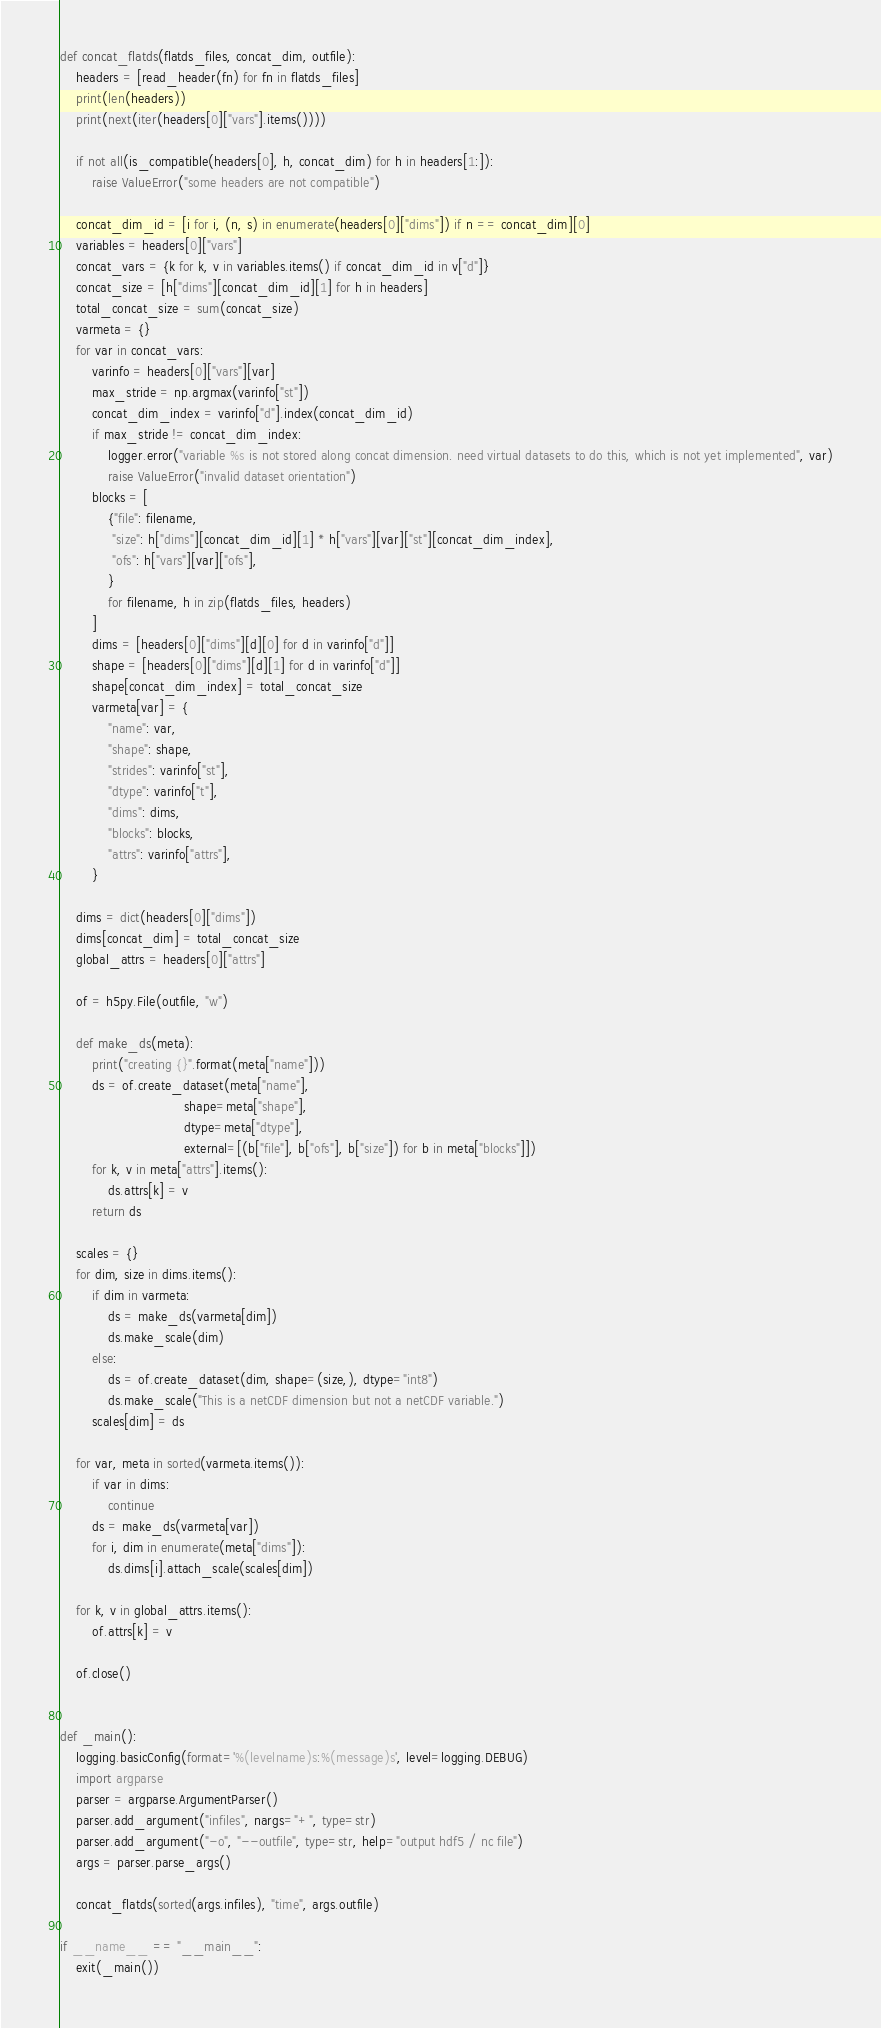<code> <loc_0><loc_0><loc_500><loc_500><_Python_>def concat_flatds(flatds_files, concat_dim, outfile):
    headers = [read_header(fn) for fn in flatds_files]
    print(len(headers))
    print(next(iter(headers[0]["vars"].items())))

    if not all(is_compatible(headers[0], h, concat_dim) for h in headers[1:]):
        raise ValueError("some headers are not compatible")

    concat_dim_id = [i for i, (n, s) in enumerate(headers[0]["dims"]) if n == concat_dim][0]
    variables = headers[0]["vars"]
    concat_vars = {k for k, v in variables.items() if concat_dim_id in v["d"]}
    concat_size = [h["dims"][concat_dim_id][1] for h in headers]
    total_concat_size = sum(concat_size)
    varmeta = {}
    for var in concat_vars:
        varinfo = headers[0]["vars"][var]
        max_stride = np.argmax(varinfo["st"])
        concat_dim_index = varinfo["d"].index(concat_dim_id)
        if max_stride != concat_dim_index:
            logger.error("variable %s is not stored along concat dimension. need virtual datasets to do this, which is not yet implemented", var)
            raise ValueError("invalid dataset orientation")
        blocks = [
            {"file": filename,
             "size": h["dims"][concat_dim_id][1] * h["vars"][var]["st"][concat_dim_index],
             "ofs": h["vars"][var]["ofs"],
            }
            for filename, h in zip(flatds_files, headers)
        ]
        dims = [headers[0]["dims"][d][0] for d in varinfo["d"]]
        shape = [headers[0]["dims"][d][1] for d in varinfo["d"]]
        shape[concat_dim_index] = total_concat_size
        varmeta[var] = {
            "name": var,
            "shape": shape,
            "strides": varinfo["st"],
            "dtype": varinfo["t"],
            "dims": dims,
            "blocks": blocks,
            "attrs": varinfo["attrs"],
        }

    dims = dict(headers[0]["dims"])
    dims[concat_dim] = total_concat_size
    global_attrs = headers[0]["attrs"]

    of = h5py.File(outfile, "w")

    def make_ds(meta):
        print("creating {}".format(meta["name"]))
        ds = of.create_dataset(meta["name"],
                               shape=meta["shape"],
                               dtype=meta["dtype"],
                               external=[(b["file"], b["ofs"], b["size"]) for b in meta["blocks"]])
        for k, v in meta["attrs"].items():
            ds.attrs[k] = v
        return ds

    scales = {}
    for dim, size in dims.items():
        if dim in varmeta:
            ds = make_ds(varmeta[dim])
            ds.make_scale(dim)
        else:
            ds = of.create_dataset(dim, shape=(size,), dtype="int8")
            ds.make_scale("This is a netCDF dimension but not a netCDF variable.")
        scales[dim] = ds

    for var, meta in sorted(varmeta.items()):
        if var in dims:
            continue
        ds = make_ds(varmeta[var])
        for i, dim in enumerate(meta["dims"]):
            ds.dims[i].attach_scale(scales[dim])

    for k, v in global_attrs.items():
        of.attrs[k] = v

    of.close()


def _main():
    logging.basicConfig(format='%(levelname)s:%(message)s', level=logging.DEBUG)
    import argparse
    parser = argparse.ArgumentParser()
    parser.add_argument("infiles", nargs="+", type=str)
    parser.add_argument("-o", "--outfile", type=str, help="output hdf5 / nc file")
    args = parser.parse_args()

    concat_flatds(sorted(args.infiles), "time", args.outfile)

if __name__ == "__main__":
    exit(_main())
</code> 